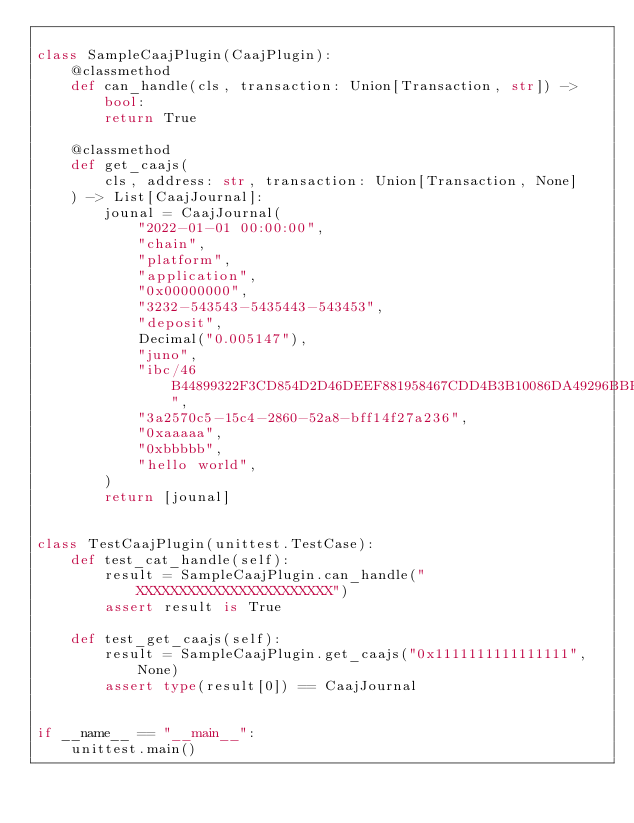<code> <loc_0><loc_0><loc_500><loc_500><_Python_>
class SampleCaajPlugin(CaajPlugin):
    @classmethod
    def can_handle(cls, transaction: Union[Transaction, str]) -> bool:
        return True

    @classmethod
    def get_caajs(
        cls, address: str, transaction: Union[Transaction, None]
    ) -> List[CaajJournal]:
        jounal = CaajJournal(
            "2022-01-01 00:00:00",
            "chain",
            "platform",
            "application",
            "0x00000000",
            "3232-543543-5435443-543453",
            "deposit",
            Decimal("0.005147"),
            "juno",
            "ibc/46B44899322F3CD854D2D46DEEF881958467CDD4B3B10086DA49296BBED94BED",
            "3a2570c5-15c4-2860-52a8-bff14f27a236",
            "0xaaaaa",
            "0xbbbbb",
            "hello world",
        )
        return [jounal]


class TestCaajPlugin(unittest.TestCase):
    def test_cat_handle(self):
        result = SampleCaajPlugin.can_handle("XXXXXXXXXXXXXXXXXXXXXXX")
        assert result is True

    def test_get_caajs(self):
        result = SampleCaajPlugin.get_caajs("0x1111111111111111", None)
        assert type(result[0]) == CaajJournal


if __name__ == "__main__":
    unittest.main()
</code> 